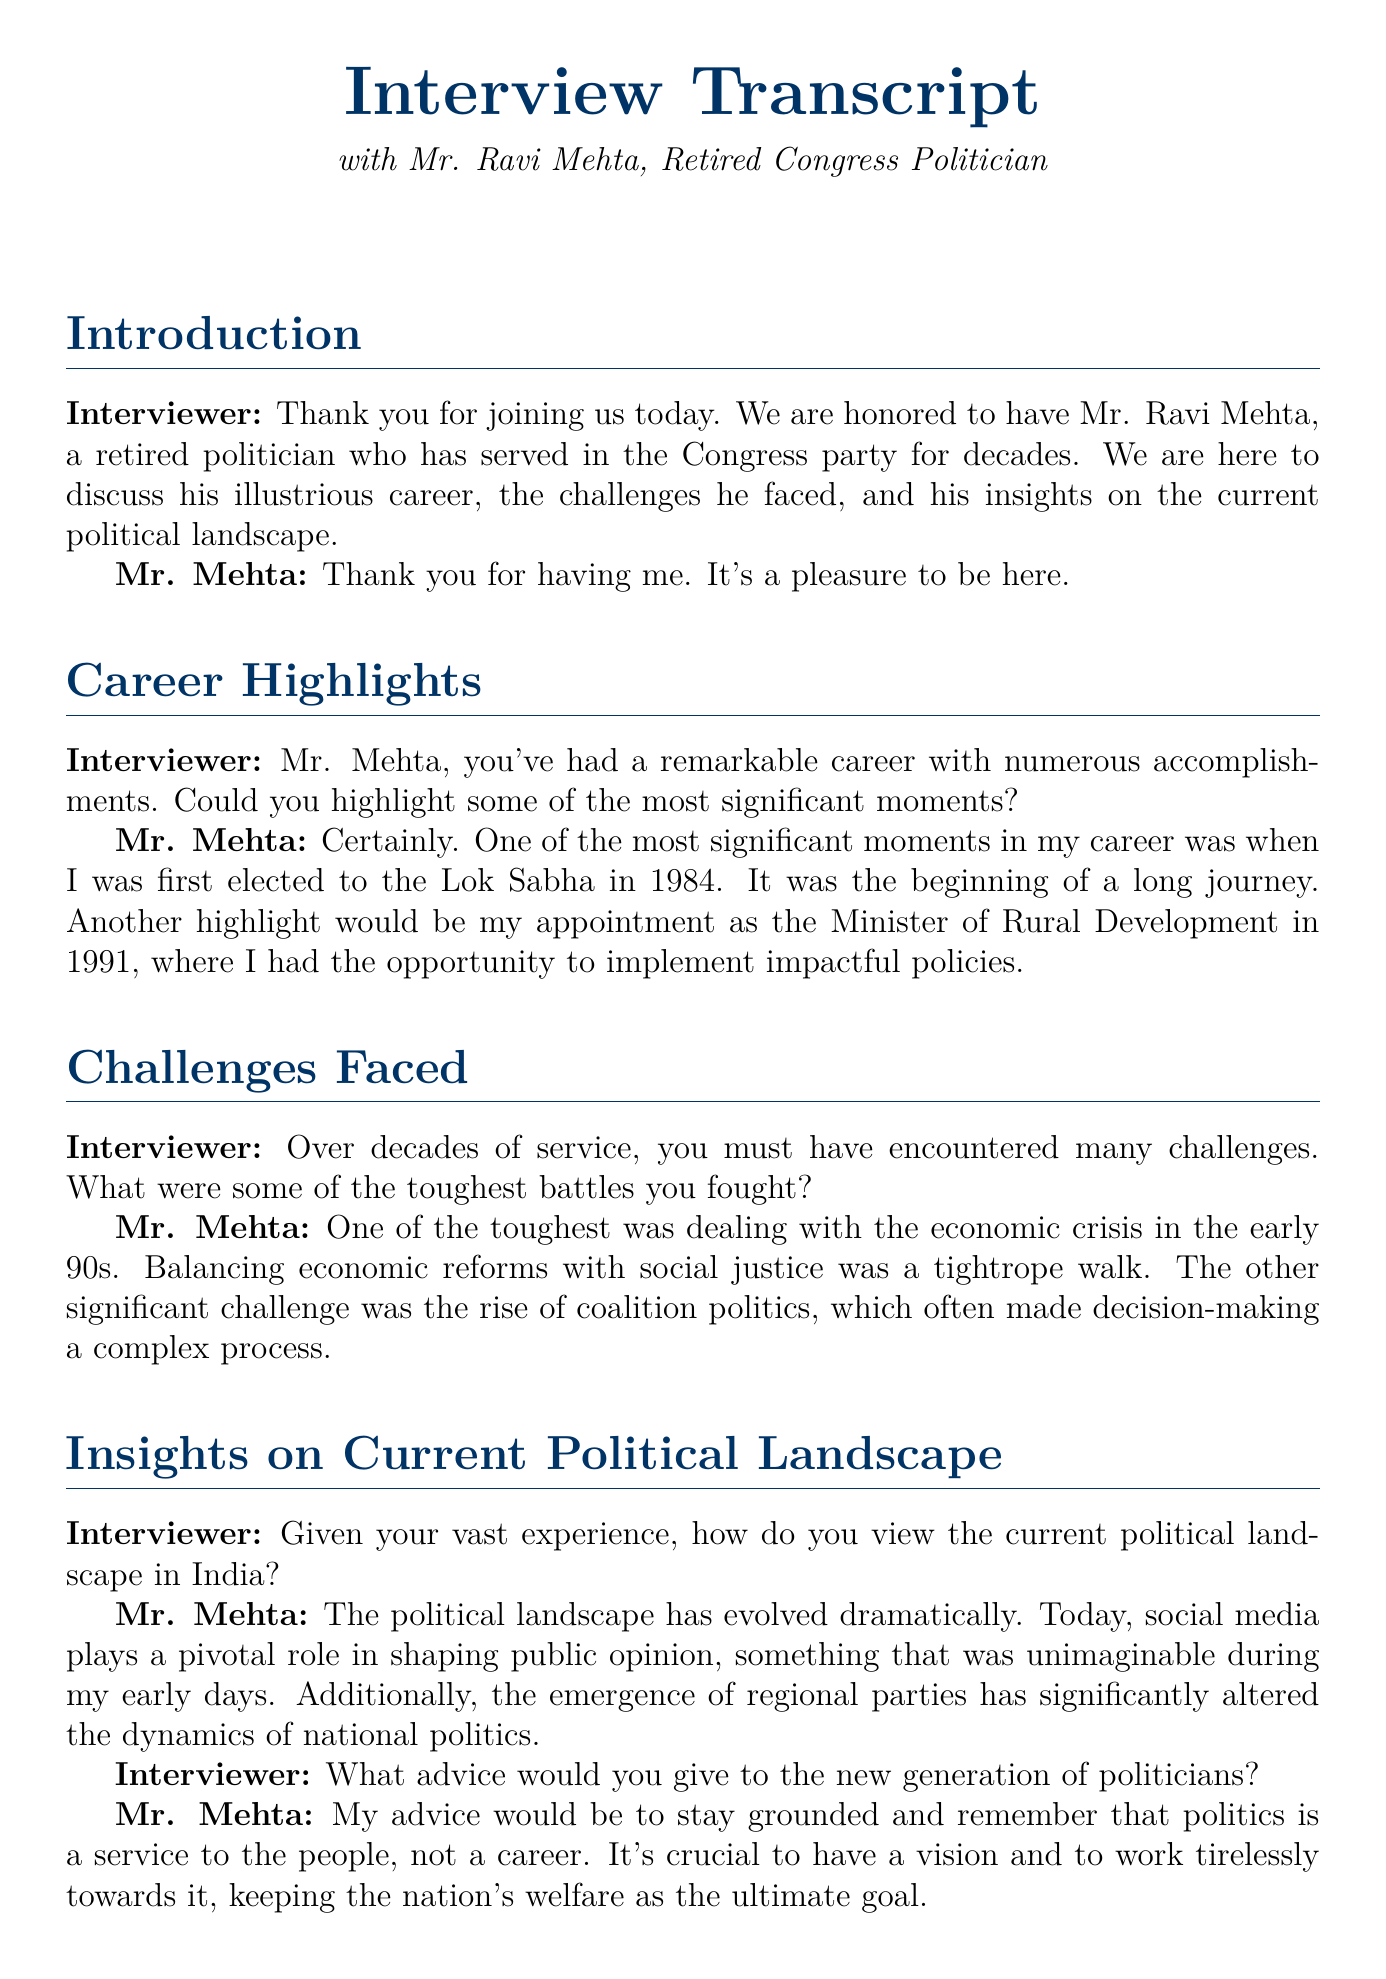What year was Mr. Mehta first elected to the Lok Sabha? Mr. Mehta states he was first elected in 1984, which is a significant moment in his career.
Answer: 1984 What position did Mr. Mehta hold in 1991? In 1991, Mr. Mehta was appointed as the Minister of Rural Development, which he highlights as a career achievement.
Answer: Minister of Rural Development What economic issue did Mr. Mehta face in the early 90s? Mr. Mehta refers to the economic crisis as one of the toughest challenges he faced during his political career.
Answer: Economic crisis What new factor does Mr. Mehta mention as influencing public opinion today? Mr. Mehta notes the role of social media as a pivotal influence on public opinion in the current political landscape.
Answer: Social media What advice does Mr. Mehta give to new politicians? Mr. Mehta advises new politicians to stay grounded and view politics as a service to the people, not just a career.
Answer: Stay grounded What is Mr. Mehta's view on the emergence of regional parties? Mr. Mehta observes that the rise of regional parties has significantly altered the dynamics of national politics.
Answer: Altered dynamics What was the interviewer’s sentiment towards Mr. Mehta’s insights? The interviewer expresses appreciation for Mr. Mehta's sharing of experiences and insights during the conversation.
Answer: Enlightening How many decades did Mr. Mehta serve in the Congress party? Mr. Mehta served for decades in the Congress party, indicating a lengthy career in politics.
Answer: Decades 